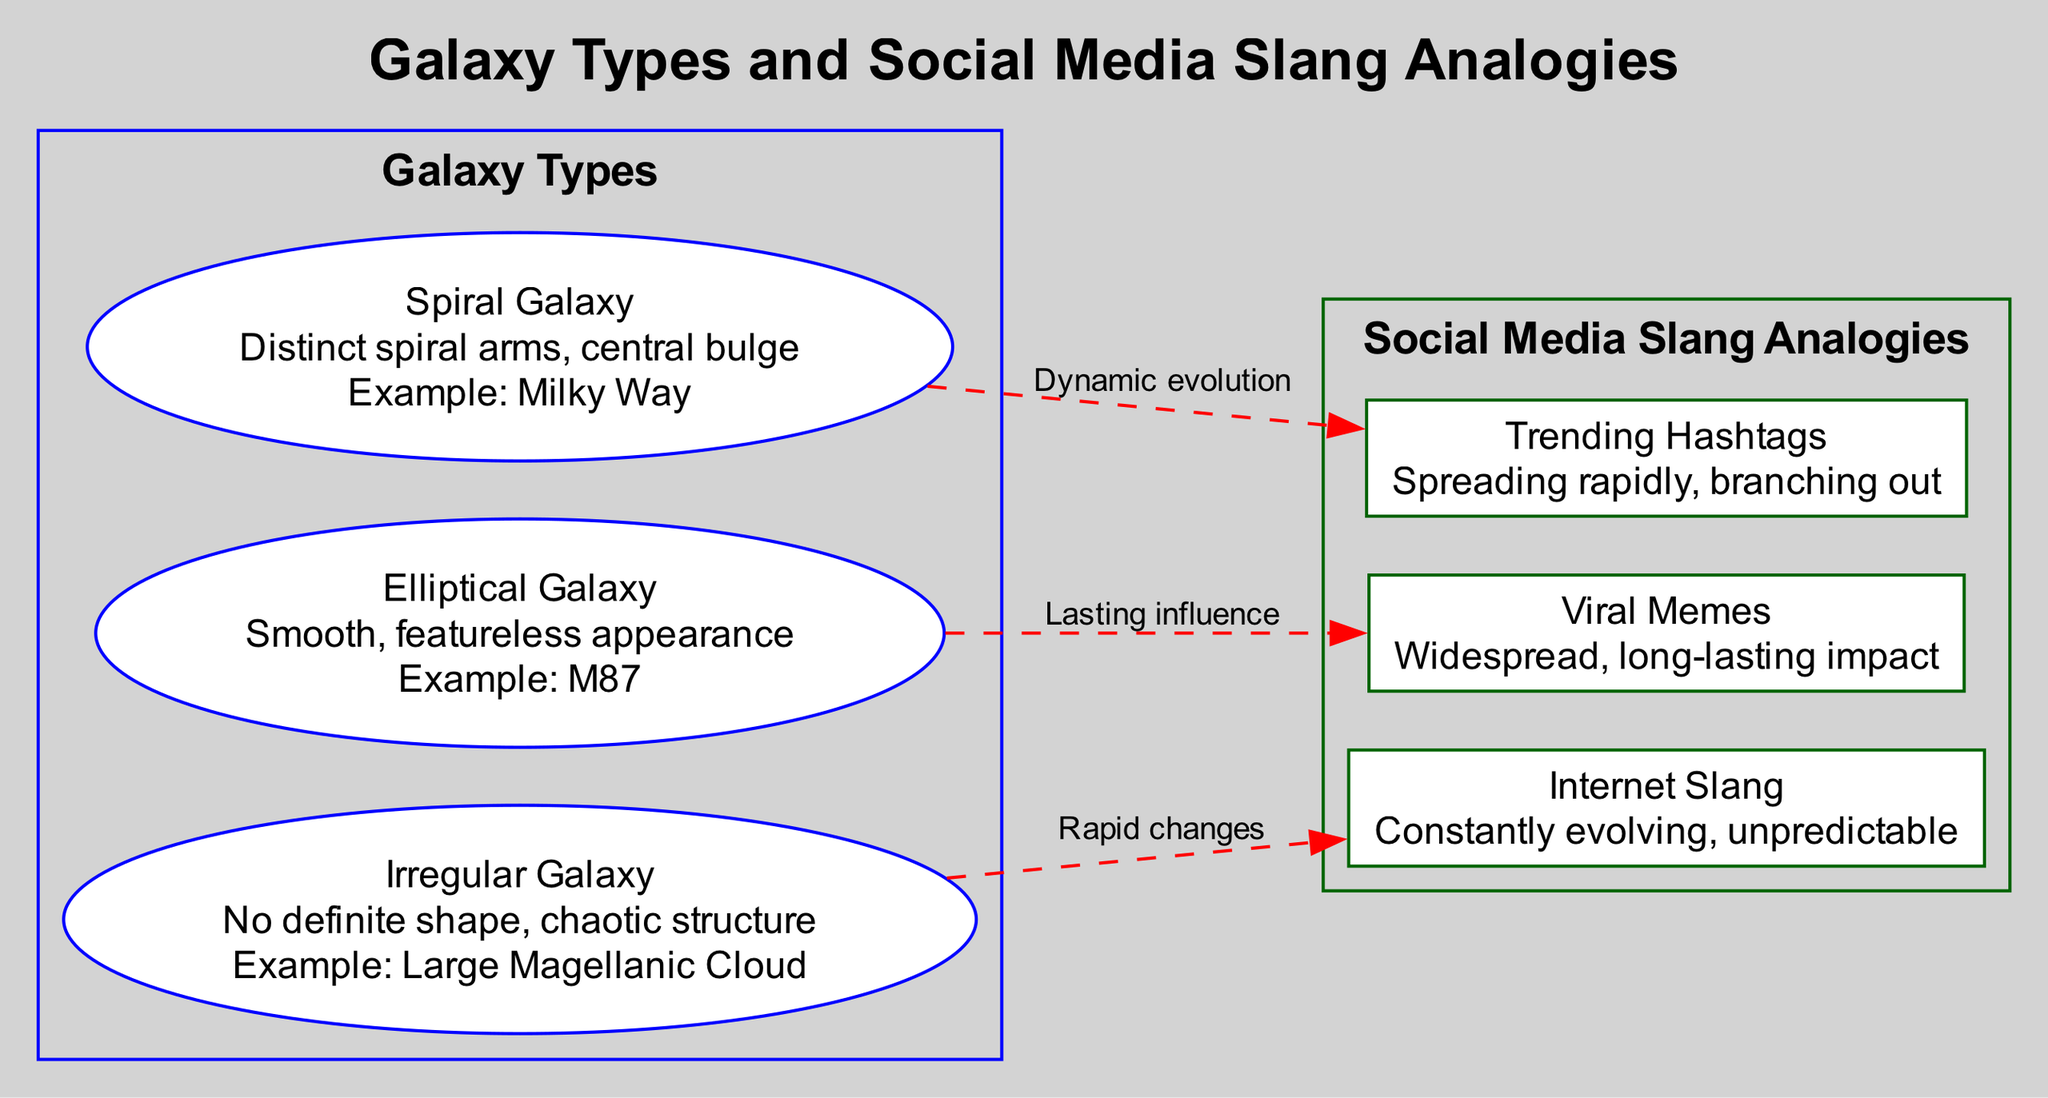What types of galaxies are presented in the diagram? The diagram lists three types of galaxies: Spiral, Elliptical, and Irregular.
Answer: Spiral, Elliptical, Irregular What is the feature of the Spiral Galaxy? The feature of the Spiral Galaxy is "Distinct spiral arms, central bulge."
Answer: Distinct spiral arms, central bulge How many connections are shown in the diagram? The diagram showcases three connections between galaxy types and their slang analogs.
Answer: 3 What is the slang analogy for the Elliptical Galaxy? The slang analogy for the Elliptical Galaxy is "Viral Memes."
Answer: Viral Memes What does "Trending Hashtags" represent in the context of the diagram? "Trending Hashtags" represents the slang analogy for the Spiral Galaxy, highlighting its dynamic evolution.
Answer: Dynamic evolution Which galaxy type is characterized by a chaotic structure? The galaxy type characterized by a chaotic structure is the Irregular Galaxy.
Answer: Irregular Galaxy Explain the relationship between Elliptical Galaxy and Viral Memes. The diagram specifically states that there is a connection labeled "Lasting influence" between the Elliptical Galaxy and Viral Memes, indicating their extensive impact.
Answer: Lasting influence What does the "Rapid changes" label connect to? The "Rapid changes" label connects the Irregular Galaxy to the Internet Slang, depicting the unpredictability of slang evolution.
Answer: Internet Slang How does the Spiral Galaxy relate to social media evolution? The Spiral Galaxy is linked to "Trending Hashtags," indicating a representation of dynamic evolution in social media trends.
Answer: Dynamic evolution 